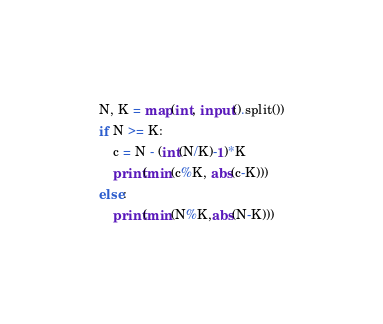Convert code to text. <code><loc_0><loc_0><loc_500><loc_500><_Python_>N, K = map(int, input().split())
if N >= K:
    c = N - (int(N/K)-1)*K
    print(min(c%K, abs(c-K)))
else:
    print(min(N%K,abs(N-K)))</code> 